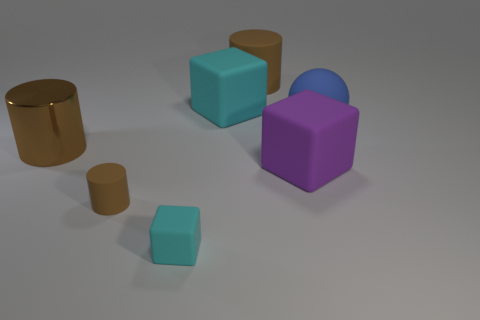How many objects are both behind the tiny cyan block and on the left side of the large blue rubber sphere?
Your answer should be very brief. 5. What is the material of the sphere that is the same size as the brown shiny cylinder?
Your answer should be very brief. Rubber. Are there an equal number of matte cubes in front of the blue matte object and purple matte cubes behind the metal cylinder?
Provide a succinct answer. No. There is a metal object; is it the same color as the rubber cylinder behind the large blue rubber object?
Give a very brief answer. Yes. There is a cyan thing that is the same material as the big cyan cube; what is its size?
Make the answer very short. Small. Are the sphere and the big brown cylinder that is behind the big brown metal cylinder made of the same material?
Give a very brief answer. Yes. There is a small thing that is the same shape as the large cyan rubber thing; what material is it?
Your answer should be very brief. Rubber. Is there anything else that is the same material as the large blue ball?
Make the answer very short. Yes. Is the number of brown metallic objects left of the big shiny object greater than the number of large matte blocks that are to the right of the big rubber ball?
Provide a short and direct response. No. There is a purple thing that is made of the same material as the tiny cyan cube; what is its shape?
Offer a very short reply. Cube. 